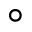Convert formula to latex. <formula><loc_0><loc_0><loc_500><loc_500>^ { \circ }</formula> 